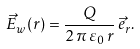Convert formula to latex. <formula><loc_0><loc_0><loc_500><loc_500>\vec { E } _ { w } ( r ) = \frac { Q } { 2 \, \pi \, \varepsilon _ { 0 } \, r } \, \vec { e } _ { r } .</formula> 